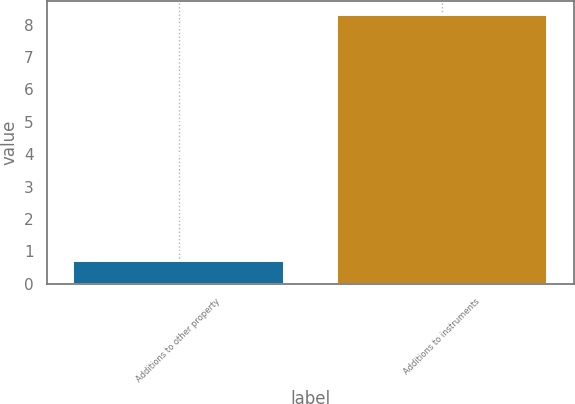Convert chart to OTSL. <chart><loc_0><loc_0><loc_500><loc_500><bar_chart><fcel>Additions to other property<fcel>Additions to instruments<nl><fcel>0.7<fcel>8.3<nl></chart> 